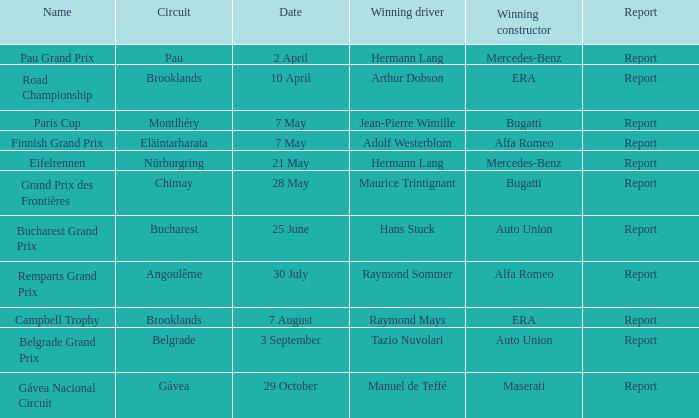Show the account for 30 july. Report. Could you parse the entire table? {'header': ['Name', 'Circuit', 'Date', 'Winning driver', 'Winning constructor', 'Report'], 'rows': [['Pau Grand Prix', 'Pau', '2 April', 'Hermann Lang', 'Mercedes-Benz', 'Report'], ['Road Championship', 'Brooklands', '10 April', 'Arthur Dobson', 'ERA', 'Report'], ['Paris Cup', 'Montlhéry', '7 May', 'Jean-Pierre Wimille', 'Bugatti', 'Report'], ['Finnish Grand Prix', 'Eläintarharata', '7 May', 'Adolf Westerblom', 'Alfa Romeo', 'Report'], ['Eifelrennen', 'Nürburgring', '21 May', 'Hermann Lang', 'Mercedes-Benz', 'Report'], ['Grand Prix des Frontières', 'Chimay', '28 May', 'Maurice Trintignant', 'Bugatti', 'Report'], ['Bucharest Grand Prix', 'Bucharest', '25 June', 'Hans Stuck', 'Auto Union', 'Report'], ['Remparts Grand Prix', 'Angoulême', '30 July', 'Raymond Sommer', 'Alfa Romeo', 'Report'], ['Campbell Trophy', 'Brooklands', '7 August', 'Raymond Mays', 'ERA', 'Report'], ['Belgrade Grand Prix', 'Belgrade', '3 September', 'Tazio Nuvolari', 'Auto Union', 'Report'], ['Gávea Nacional Circuit', 'Gávea', '29 October', 'Manuel de Teffé', 'Maserati', 'Report']]} 